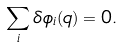<formula> <loc_0><loc_0><loc_500><loc_500>\sum _ { i } \delta \phi _ { i } ( q ) = 0 .</formula> 